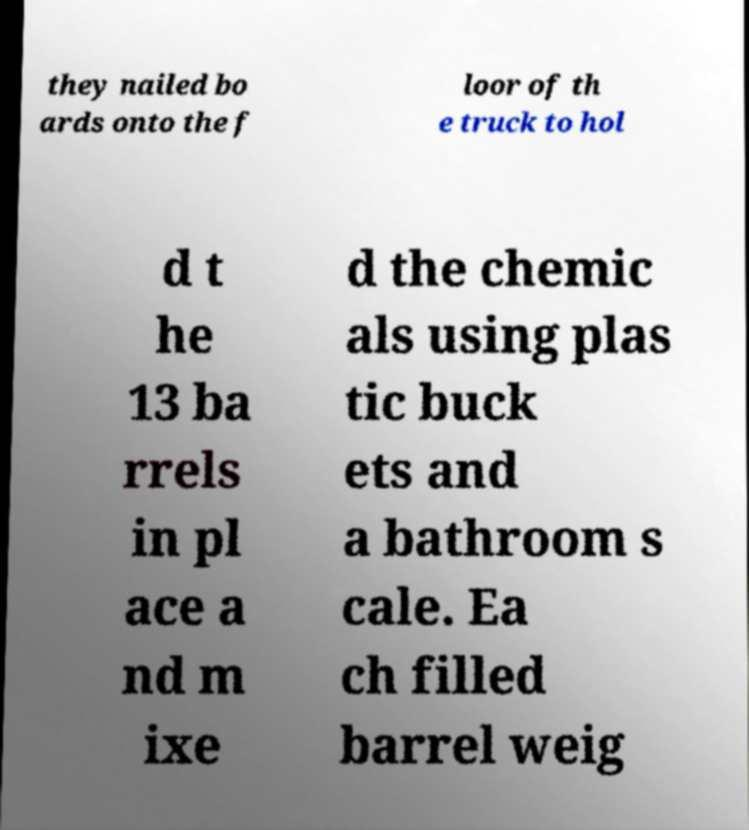Could you extract and type out the text from this image? they nailed bo ards onto the f loor of th e truck to hol d t he 13 ba rrels in pl ace a nd m ixe d the chemic als using plas tic buck ets and a bathroom s cale. Ea ch filled barrel weig 